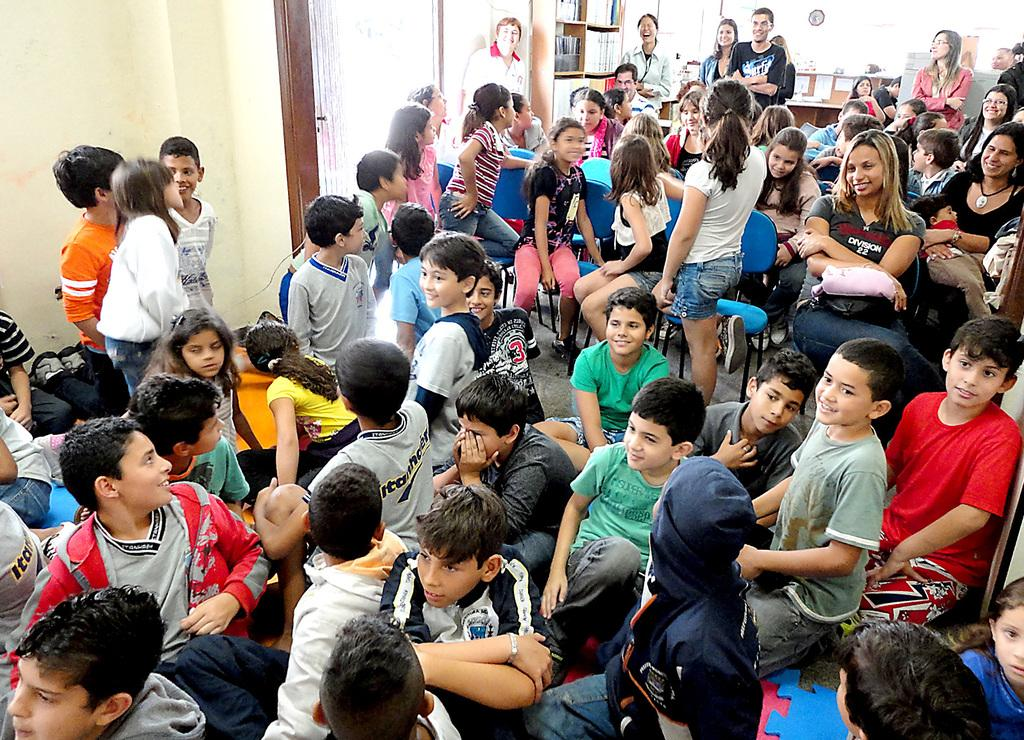How many people are in the group in the image? There is a group of people in the image, but the exact number cannot be determined from the provided facts. What are the people in the group doing? Some people are sitting, while others are standing. Some people in the group are also smiling. What can be seen in the background of the image? There is a wall and a wooden shelf in the background of the image. What objects are placed in the scene? The provided facts do not specify the objects placed in the scene. What type of payment is being made by the people in the image? There is no indication of any payment being made in the image. The people are simply sitting, standing, and smiling in a group. 